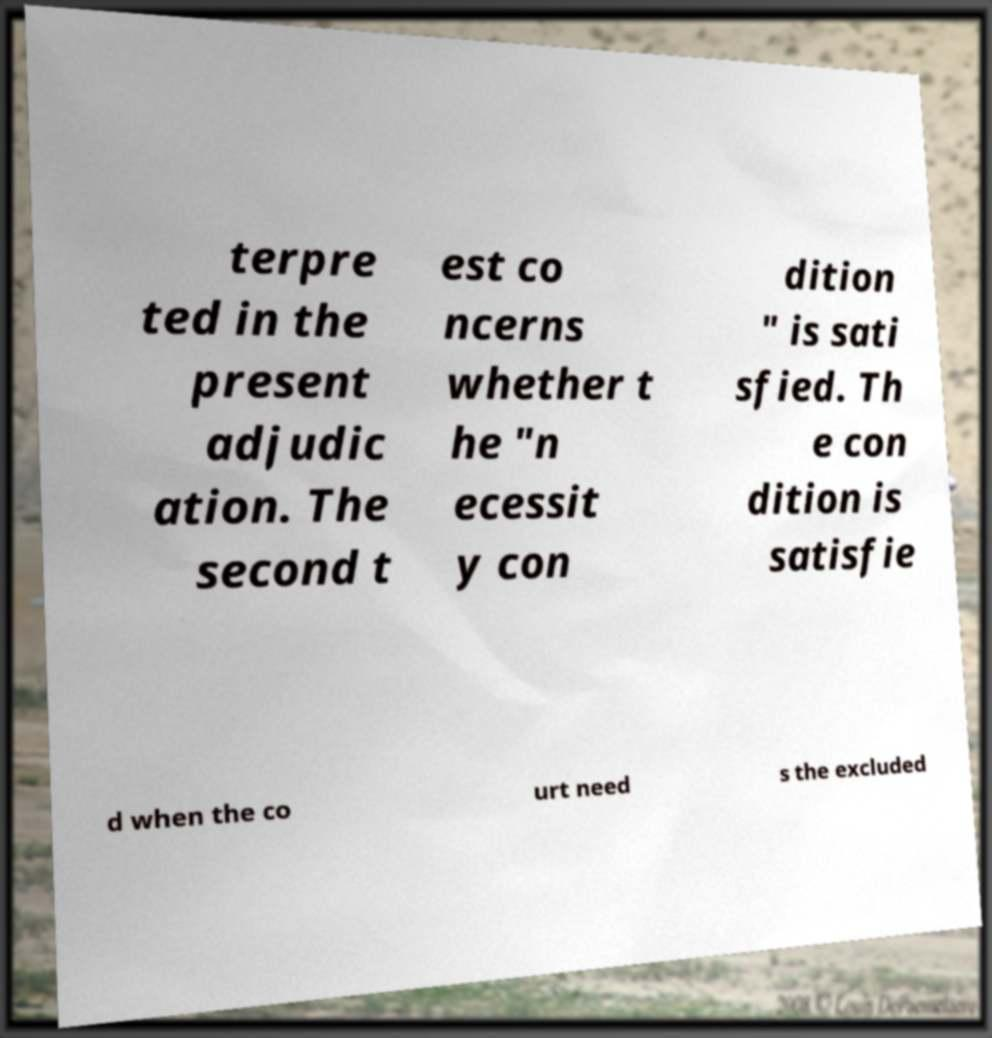I need the written content from this picture converted into text. Can you do that? terpre ted in the present adjudic ation. The second t est co ncerns whether t he "n ecessit y con dition " is sati sfied. Th e con dition is satisfie d when the co urt need s the excluded 